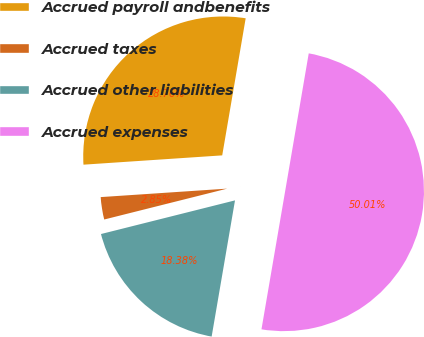Convert chart. <chart><loc_0><loc_0><loc_500><loc_500><pie_chart><fcel>Accrued payroll andbenefits<fcel>Accrued taxes<fcel>Accrued other liabilities<fcel>Accrued expenses<nl><fcel>28.76%<fcel>2.85%<fcel>18.38%<fcel>50.0%<nl></chart> 